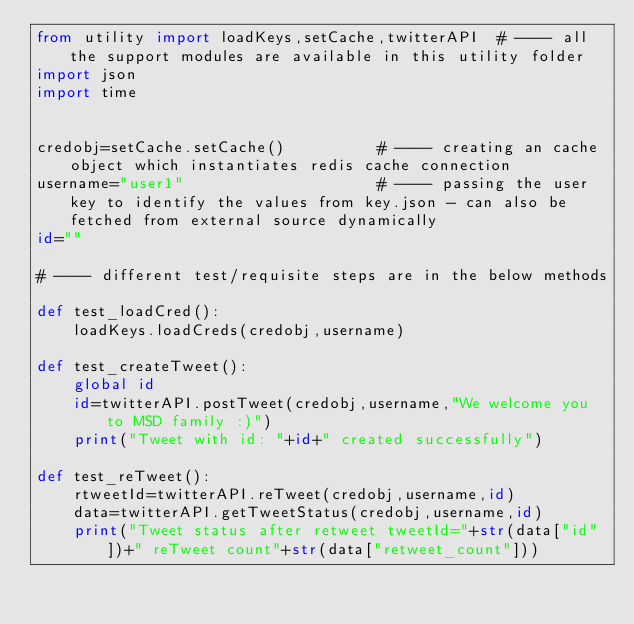Convert code to text. <code><loc_0><loc_0><loc_500><loc_500><_Python_>from utility import loadKeys,setCache,twitterAPI  # ---- all the support modules are available in this utility folder
import json
import time


credobj=setCache.setCache()          # ---- creating an cache object which instantiates redis cache connection
username="user1"                     # ---- passing the user key to identify the values from key.json - can also be fetched from external source dynamically
id=""

# ---- different test/requisite steps are in the below methods

def test_loadCred():
    loadKeys.loadCreds(credobj,username)

def test_createTweet():
    global id
    id=twitterAPI.postTweet(credobj,username,"We welcome you to MSD family :)")
    print("Tweet with id: "+id+" created successfully")

def test_reTweet():
    rtweetId=twitterAPI.reTweet(credobj,username,id)
    data=twitterAPI.getTweetStatus(credobj,username,id)
    print("Tweet status after retweet tweetId="+str(data["id"])+" reTweet count"+str(data["retweet_count"]))</code> 